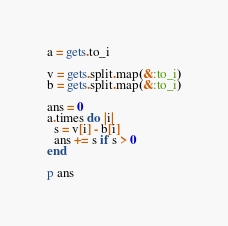Convert code to text. <code><loc_0><loc_0><loc_500><loc_500><_Ruby_>a = gets.to_i

v = gets.split.map(&:to_i)
b = gets.split.map(&:to_i)

ans = 0
a.times do |i|
  s = v[i] - b[i]
  ans += s if s > 0
end

p ans</code> 